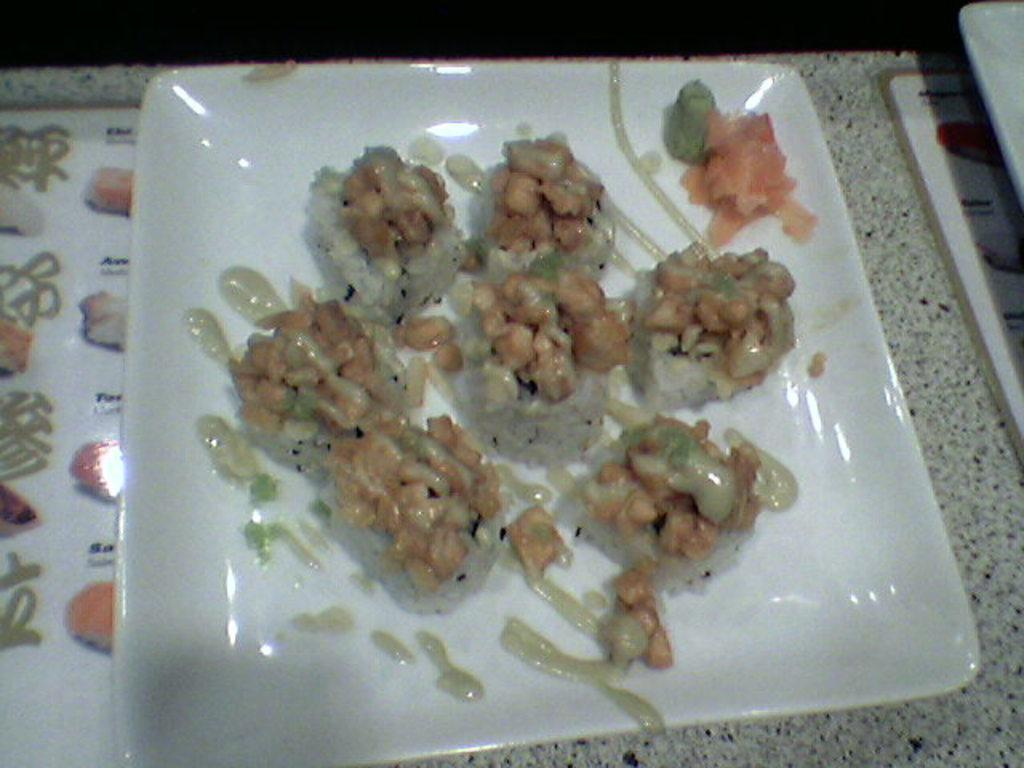What is on the plate in the image? There is food on a plate in the image. What accompanies the food on the plate? There is sauce on the plate. What color is the plate? The plate is white. What is the material of the table? The table is wooden. Where is the writer sitting in the image? There is no writer present in the image. 